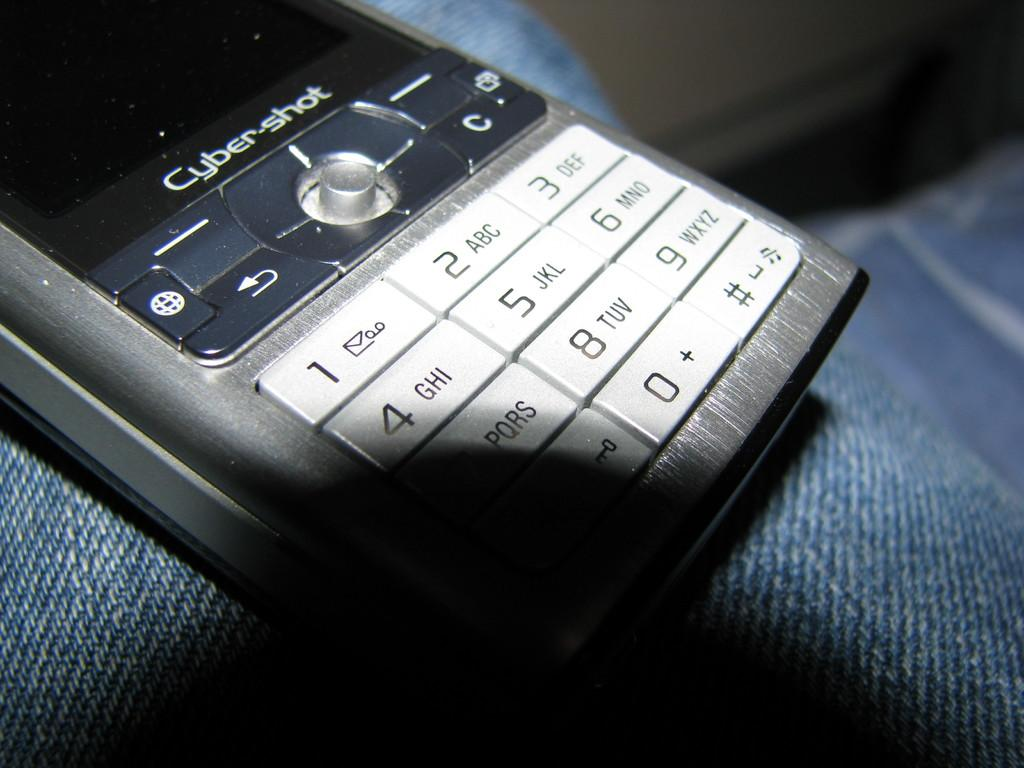<image>
Render a clear and concise summary of the photo. A Cyber Shot phone sits on top of a pair of denim 